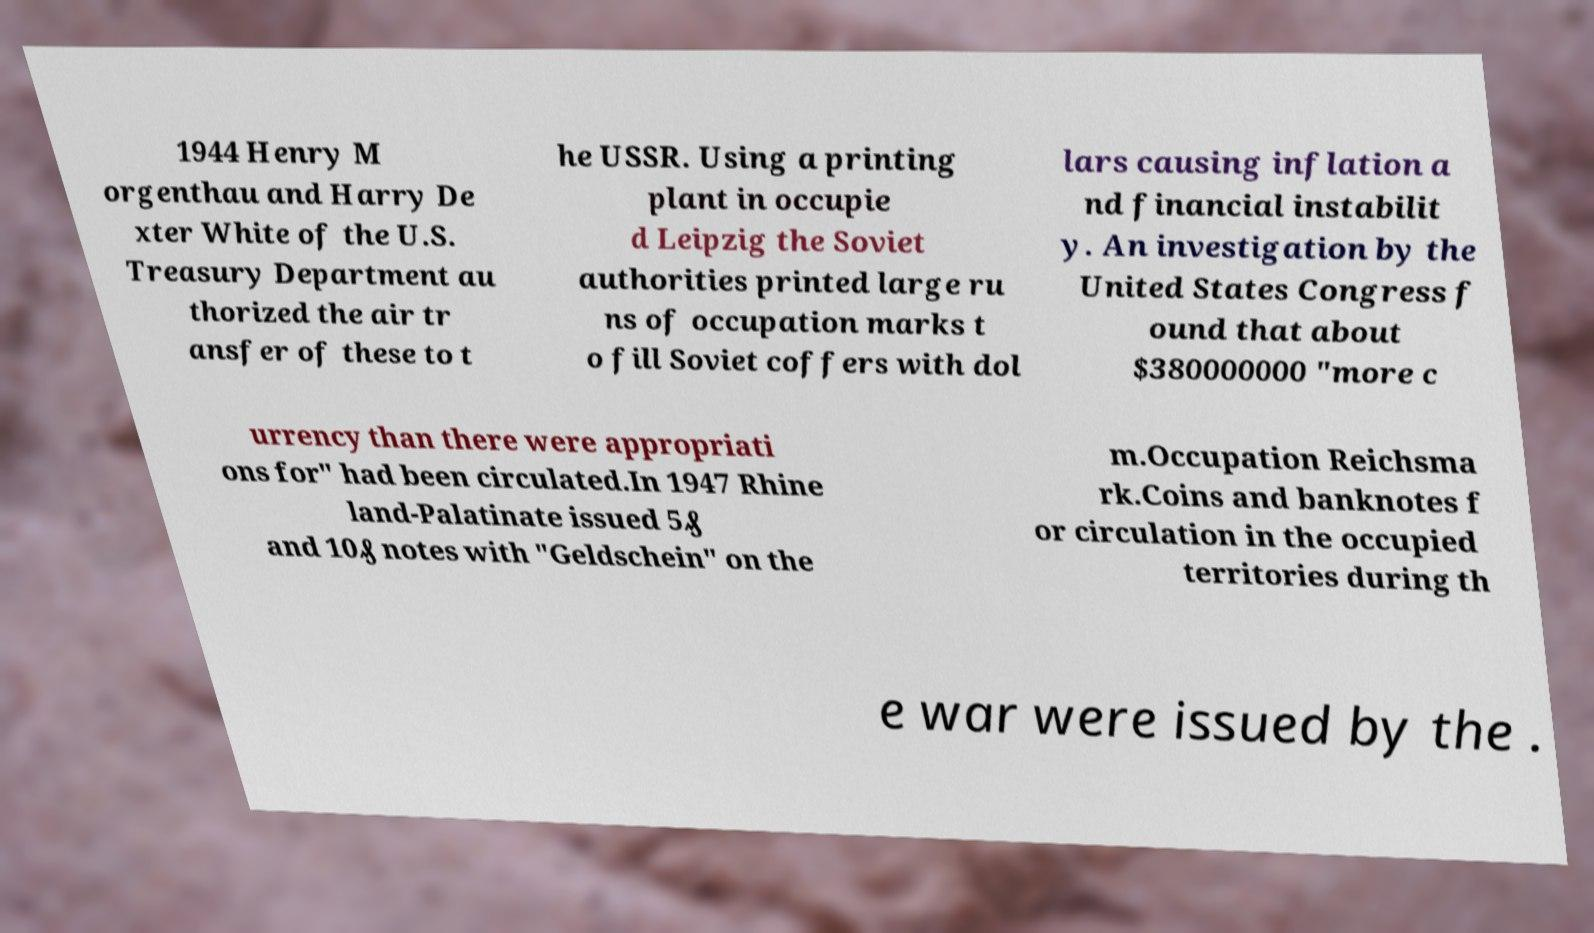What messages or text are displayed in this image? I need them in a readable, typed format. 1944 Henry M orgenthau and Harry De xter White of the U.S. Treasury Department au thorized the air tr ansfer of these to t he USSR. Using a printing plant in occupie d Leipzig the Soviet authorities printed large ru ns of occupation marks t o fill Soviet coffers with dol lars causing inflation a nd financial instabilit y. An investigation by the United States Congress f ound that about $380000000 "more c urrency than there were appropriati ons for" had been circulated.In 1947 Rhine land-Palatinate issued 5₰ and 10₰ notes with "Geldschein" on the m.Occupation Reichsma rk.Coins and banknotes f or circulation in the occupied territories during th e war were issued by the . 